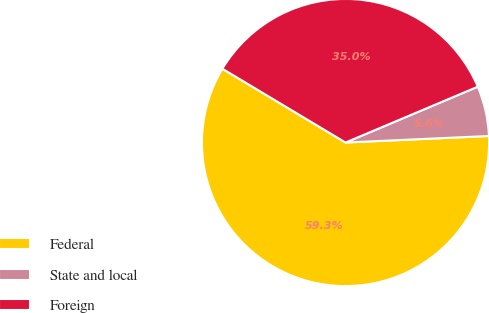Convert chart. <chart><loc_0><loc_0><loc_500><loc_500><pie_chart><fcel>Federal<fcel>State and local<fcel>Foreign<nl><fcel>59.32%<fcel>5.63%<fcel>35.05%<nl></chart> 